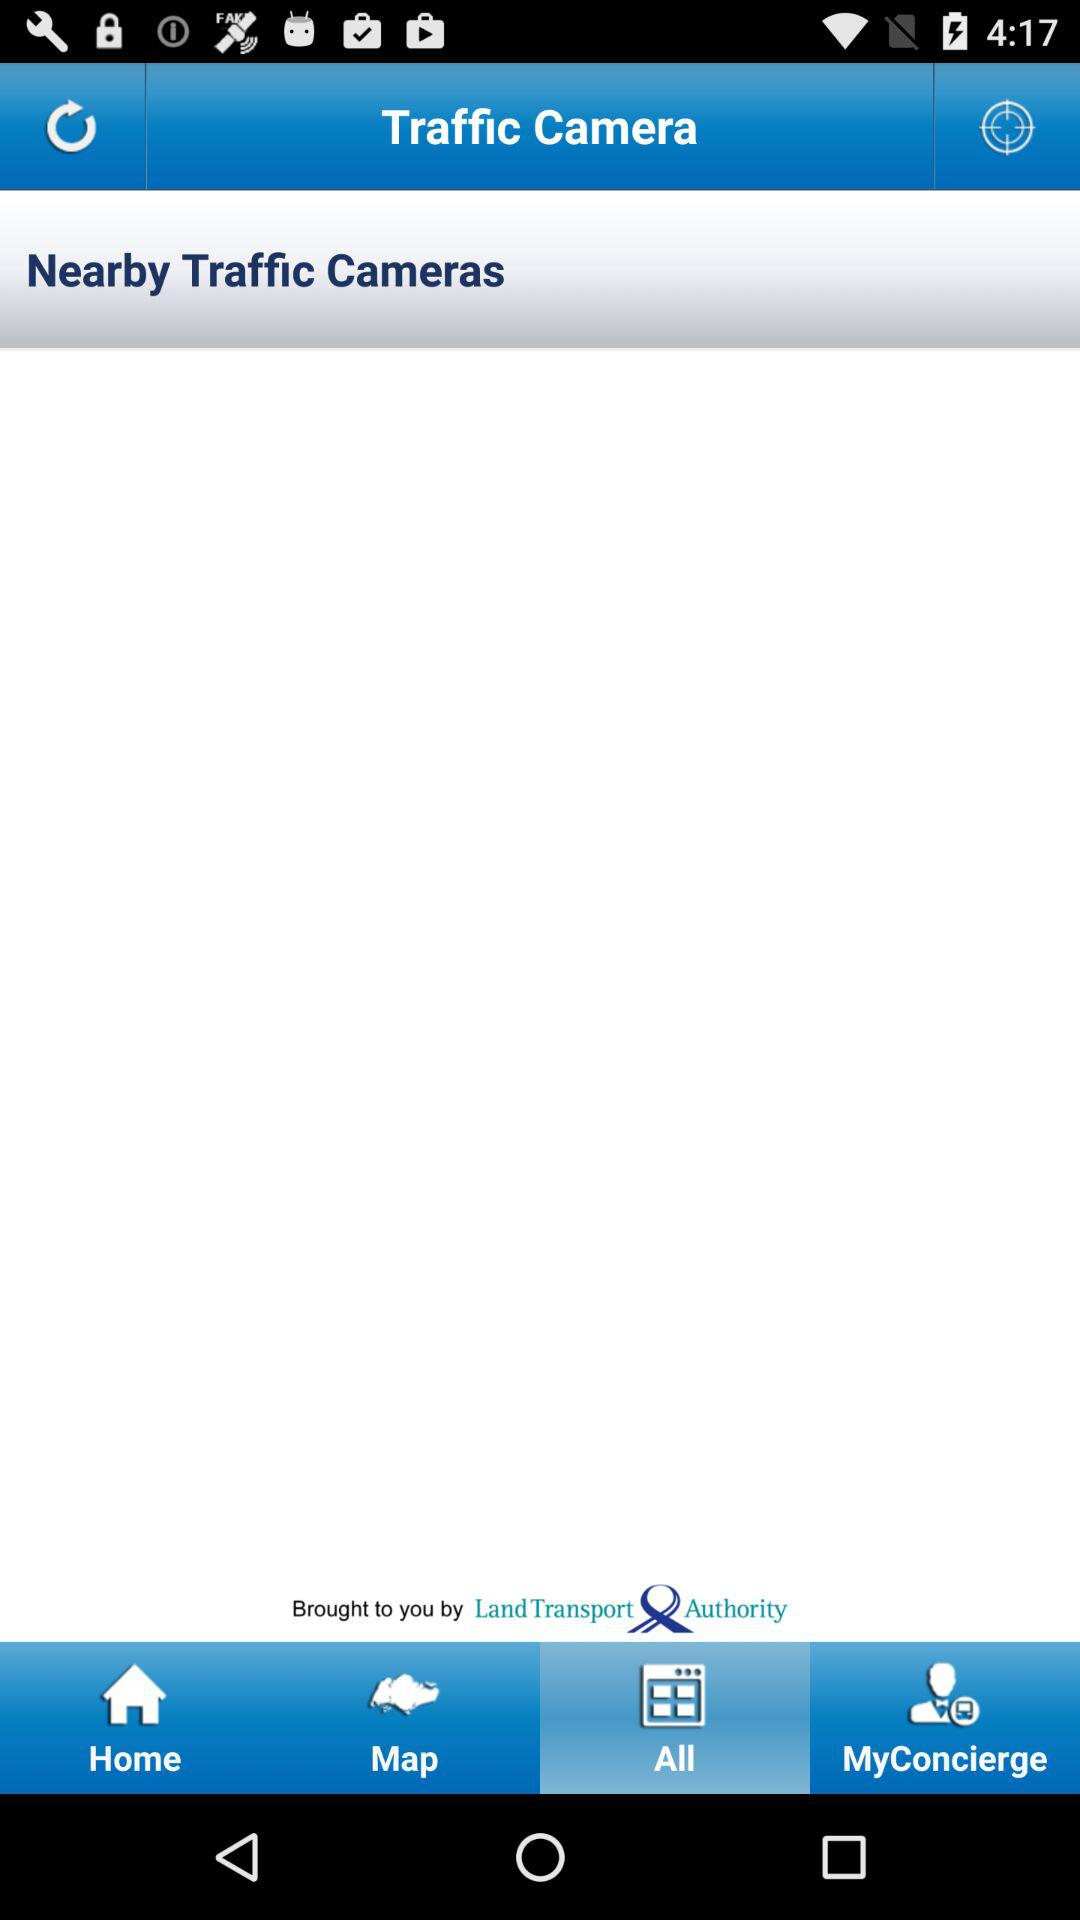What is the app name? The app name is "Traffic Camera". 